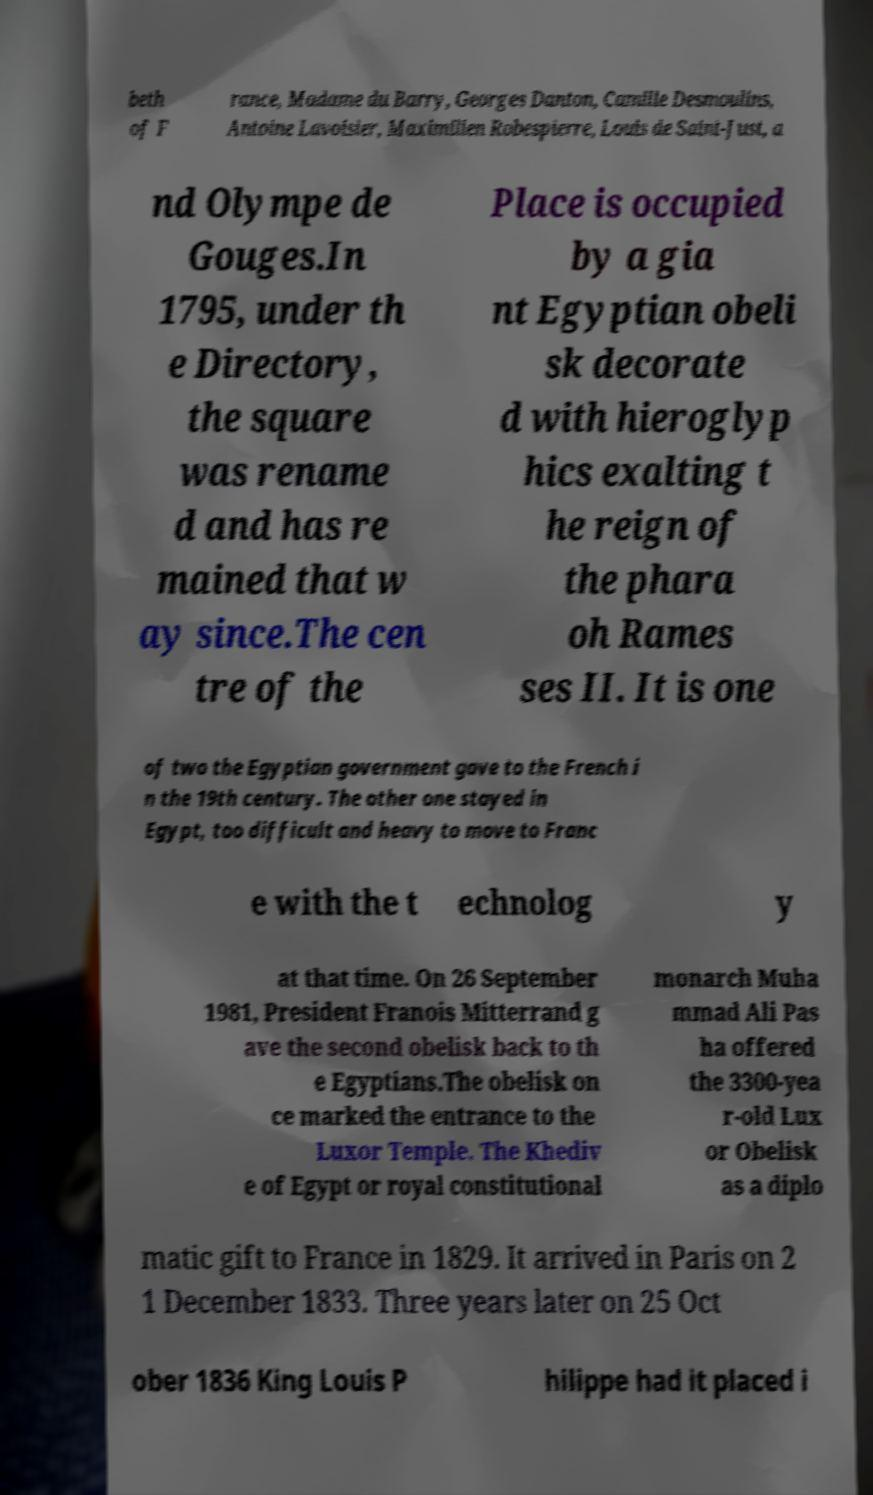There's text embedded in this image that I need extracted. Can you transcribe it verbatim? beth of F rance, Madame du Barry, Georges Danton, Camille Desmoulins, Antoine Lavoisier, Maximilien Robespierre, Louis de Saint-Just, a nd Olympe de Gouges.In 1795, under th e Directory, the square was rename d and has re mained that w ay since.The cen tre of the Place is occupied by a gia nt Egyptian obeli sk decorate d with hieroglyp hics exalting t he reign of the phara oh Rames ses II. It is one of two the Egyptian government gave to the French i n the 19th century. The other one stayed in Egypt, too difficult and heavy to move to Franc e with the t echnolog y at that time. On 26 September 1981, President Franois Mitterrand g ave the second obelisk back to th e Egyptians.The obelisk on ce marked the entrance to the Luxor Temple. The Khediv e of Egypt or royal constitutional monarch Muha mmad Ali Pas ha offered the 3300-yea r-old Lux or Obelisk as a diplo matic gift to France in 1829. It arrived in Paris on 2 1 December 1833. Three years later on 25 Oct ober 1836 King Louis P hilippe had it placed i 